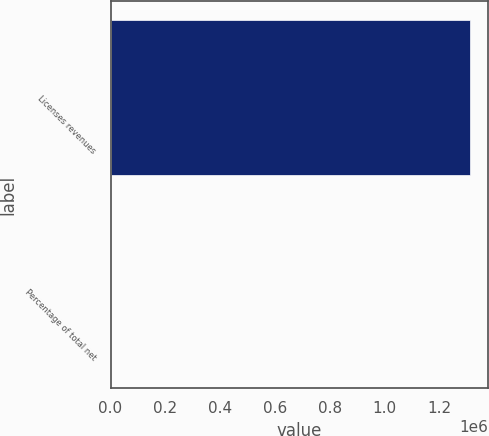Convert chart. <chart><loc_0><loc_0><loc_500><loc_500><bar_chart><fcel>Licenses revenues<fcel>Percentage of total net<nl><fcel>1.31285e+06<fcel>22<nl></chart> 